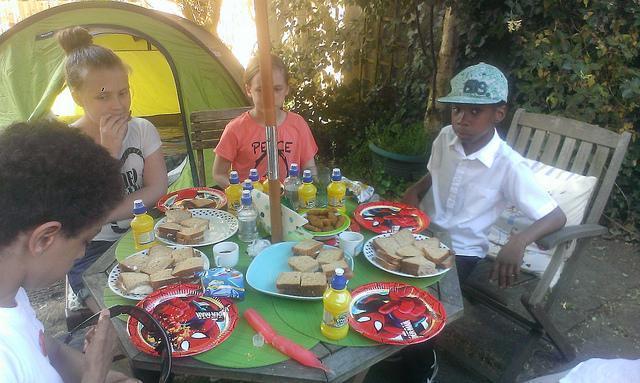How many people are at the table?
Give a very brief answer. 4. How many kids are sitting at the table?
Give a very brief answer. 4. How many people are visible?
Give a very brief answer. 4. How many elephants can you see it's trunk?
Give a very brief answer. 0. 